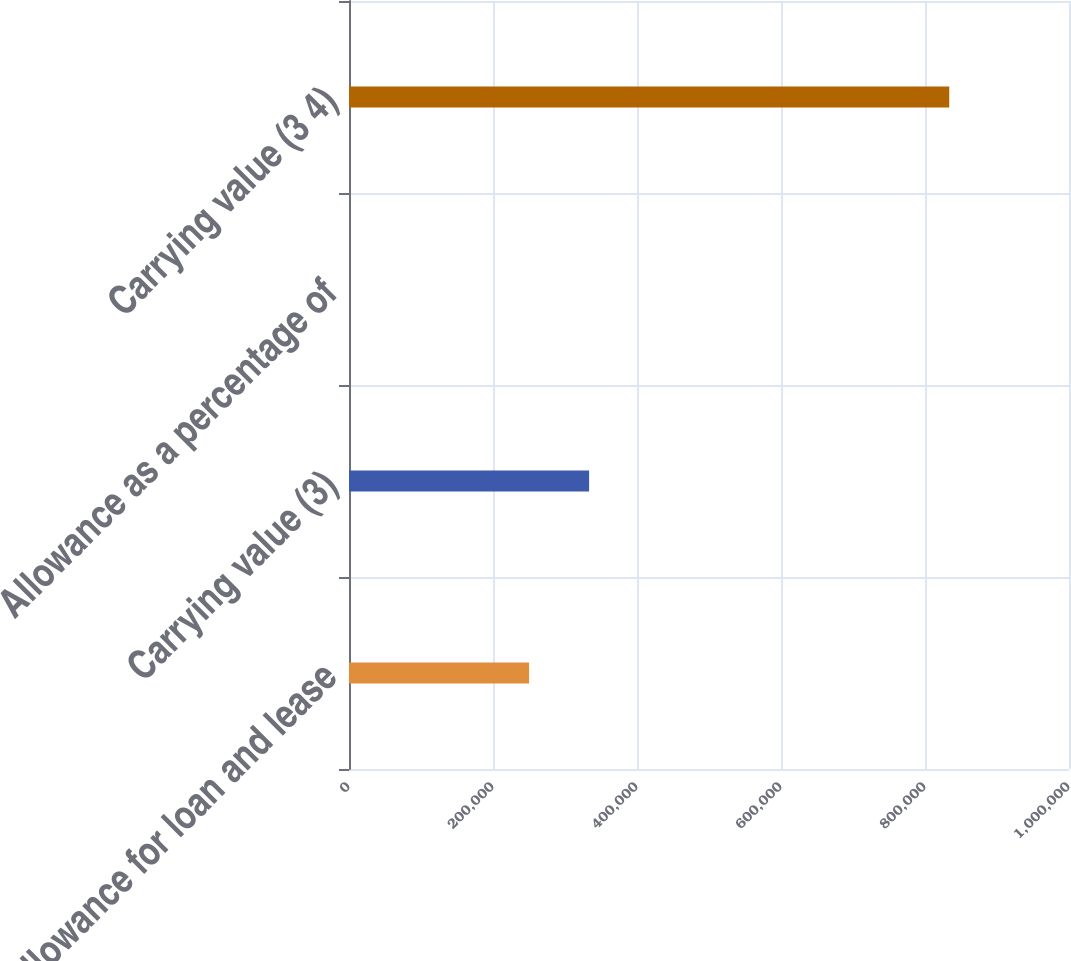Convert chart. <chart><loc_0><loc_0><loc_500><loc_500><bar_chart><fcel>Allowance for loan and lease<fcel>Carrying value (3)<fcel>Allowance as a percentage of<fcel>Carrying value (3 4)<nl><fcel>250107<fcel>333476<fcel>1.86<fcel>833687<nl></chart> 